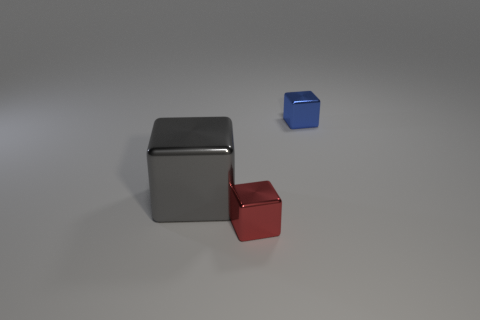Is there anything else that has the same size as the gray metal cube?
Keep it short and to the point. No. What is the shape of the other object that is the same size as the blue metallic object?
Make the answer very short. Cube. How many things are small shiny objects on the left side of the blue shiny thing or metallic cubes?
Your answer should be compact. 3. Is the number of metal cubes that are in front of the blue shiny cube greater than the number of gray metal blocks that are on the left side of the large metal cube?
Provide a short and direct response. Yes. Does the small blue object have the same material as the large gray block?
Provide a short and direct response. Yes. What shape is the shiny thing that is both right of the gray metal object and behind the small red shiny object?
Offer a very short reply. Cube. Are there any tiny brown matte cylinders?
Keep it short and to the point. No. There is a shiny cube behind the gray thing; are there any small red metal cubes in front of it?
Your answer should be compact. Yes. Is the number of tiny blue cubes greater than the number of tiny red matte balls?
Offer a very short reply. Yes. There is a big block; is it the same color as the tiny thing in front of the small blue metallic cube?
Your answer should be compact. No. 